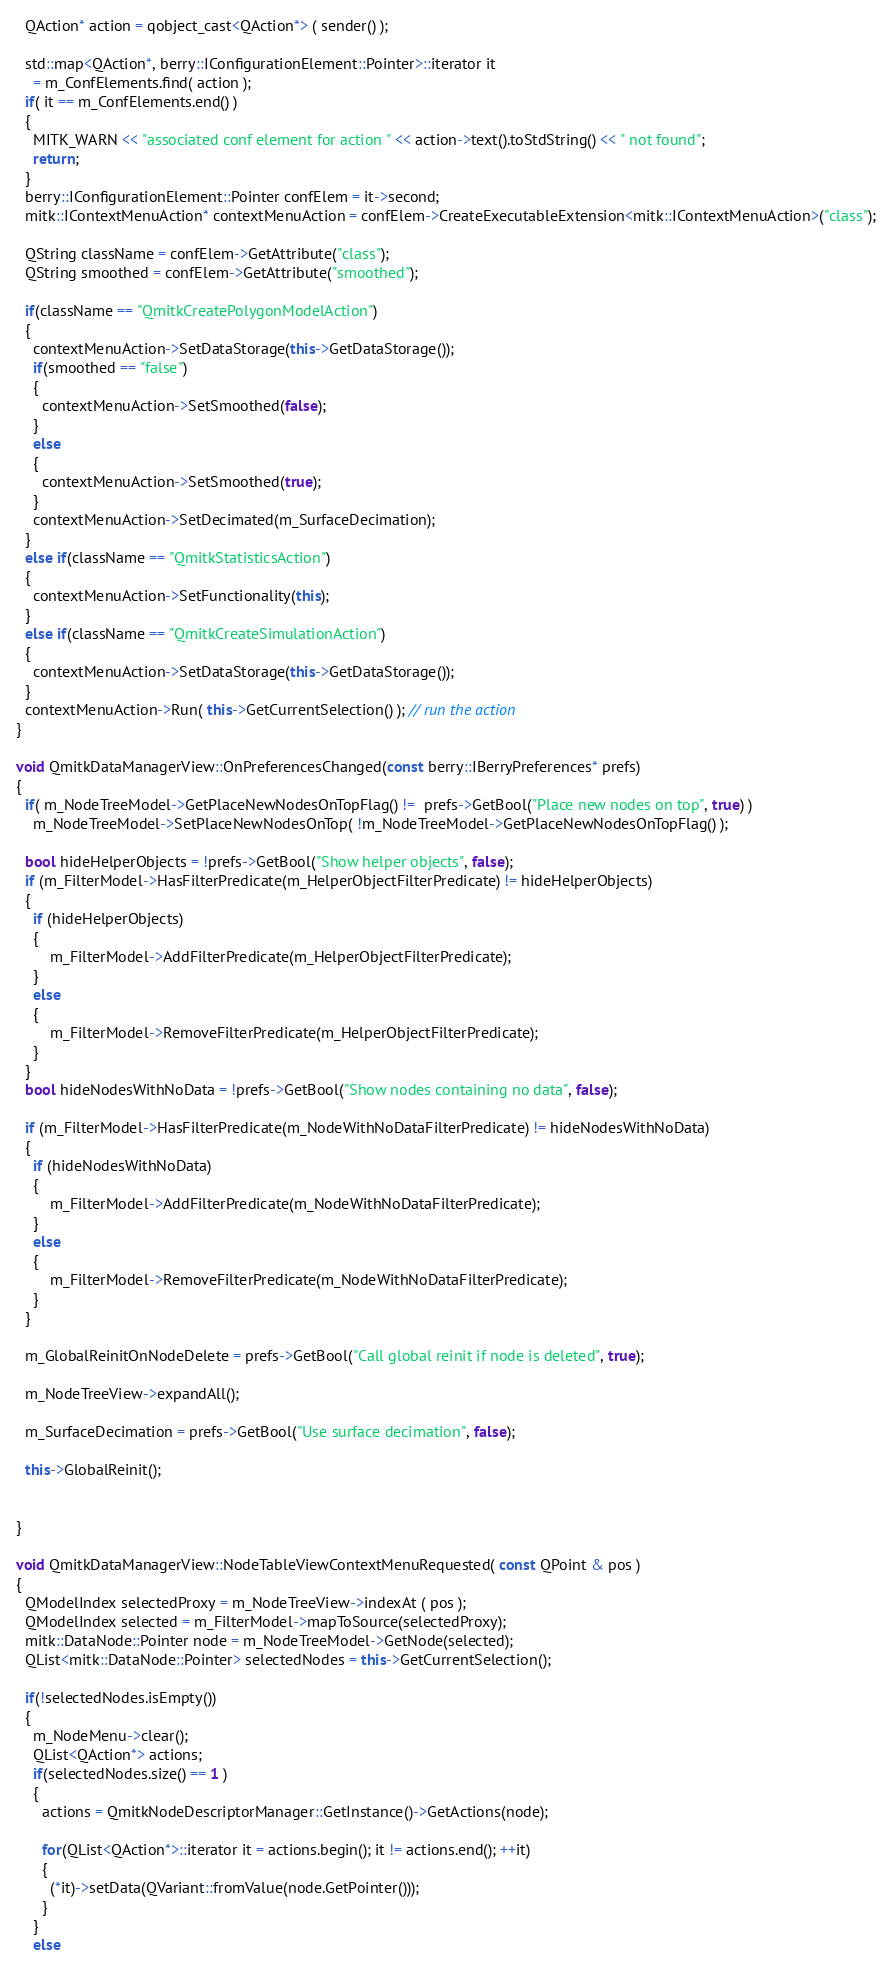Convert code to text. <code><loc_0><loc_0><loc_500><loc_500><_C++_>  QAction* action = qobject_cast<QAction*> ( sender() );

  std::map<QAction*, berry::IConfigurationElement::Pointer>::iterator it
    = m_ConfElements.find( action );
  if( it == m_ConfElements.end() )
  {
    MITK_WARN << "associated conf element for action " << action->text().toStdString() << " not found";
    return;
  }
  berry::IConfigurationElement::Pointer confElem = it->second;
  mitk::IContextMenuAction* contextMenuAction = confElem->CreateExecutableExtension<mitk::IContextMenuAction>("class");

  QString className = confElem->GetAttribute("class");
  QString smoothed = confElem->GetAttribute("smoothed");

  if(className == "QmitkCreatePolygonModelAction")
  {
    contextMenuAction->SetDataStorage(this->GetDataStorage());
    if(smoothed == "false")
    {
      contextMenuAction->SetSmoothed(false);
    }
    else
    {
      contextMenuAction->SetSmoothed(true);
    }
    contextMenuAction->SetDecimated(m_SurfaceDecimation);
  }
  else if(className == "QmitkStatisticsAction")
  {
    contextMenuAction->SetFunctionality(this);
  }
  else if(className == "QmitkCreateSimulationAction")
  {
    contextMenuAction->SetDataStorage(this->GetDataStorage());
  }
  contextMenuAction->Run( this->GetCurrentSelection() ); // run the action
}

void QmitkDataManagerView::OnPreferencesChanged(const berry::IBerryPreferences* prefs)
{
  if( m_NodeTreeModel->GetPlaceNewNodesOnTopFlag() !=  prefs->GetBool("Place new nodes on top", true) )
    m_NodeTreeModel->SetPlaceNewNodesOnTop( !m_NodeTreeModel->GetPlaceNewNodesOnTopFlag() );

  bool hideHelperObjects = !prefs->GetBool("Show helper objects", false);
  if (m_FilterModel->HasFilterPredicate(m_HelperObjectFilterPredicate) != hideHelperObjects)
  {
    if (hideHelperObjects)
    {
        m_FilterModel->AddFilterPredicate(m_HelperObjectFilterPredicate);
    }
    else
    {
        m_FilterModel->RemoveFilterPredicate(m_HelperObjectFilterPredicate);
    }
  }
  bool hideNodesWithNoData = !prefs->GetBool("Show nodes containing no data", false);

  if (m_FilterModel->HasFilterPredicate(m_NodeWithNoDataFilterPredicate) != hideNodesWithNoData)
  {
    if (hideNodesWithNoData)
    {
        m_FilterModel->AddFilterPredicate(m_NodeWithNoDataFilterPredicate);
    }
    else
    {
        m_FilterModel->RemoveFilterPredicate(m_NodeWithNoDataFilterPredicate);
    }
  }

  m_GlobalReinitOnNodeDelete = prefs->GetBool("Call global reinit if node is deleted", true);

  m_NodeTreeView->expandAll();

  m_SurfaceDecimation = prefs->GetBool("Use surface decimation", false);

  this->GlobalReinit();


}

void QmitkDataManagerView::NodeTableViewContextMenuRequested( const QPoint & pos )
{
  QModelIndex selectedProxy = m_NodeTreeView->indexAt ( pos );
  QModelIndex selected = m_FilterModel->mapToSource(selectedProxy);
  mitk::DataNode::Pointer node = m_NodeTreeModel->GetNode(selected);
  QList<mitk::DataNode::Pointer> selectedNodes = this->GetCurrentSelection();

  if(!selectedNodes.isEmpty())
  {
    m_NodeMenu->clear();
    QList<QAction*> actions;
    if(selectedNodes.size() == 1 )
    {
      actions = QmitkNodeDescriptorManager::GetInstance()->GetActions(node);

      for(QList<QAction*>::iterator it = actions.begin(); it != actions.end(); ++it)
      {
        (*it)->setData(QVariant::fromValue(node.GetPointer()));
      }
    }
    else</code> 